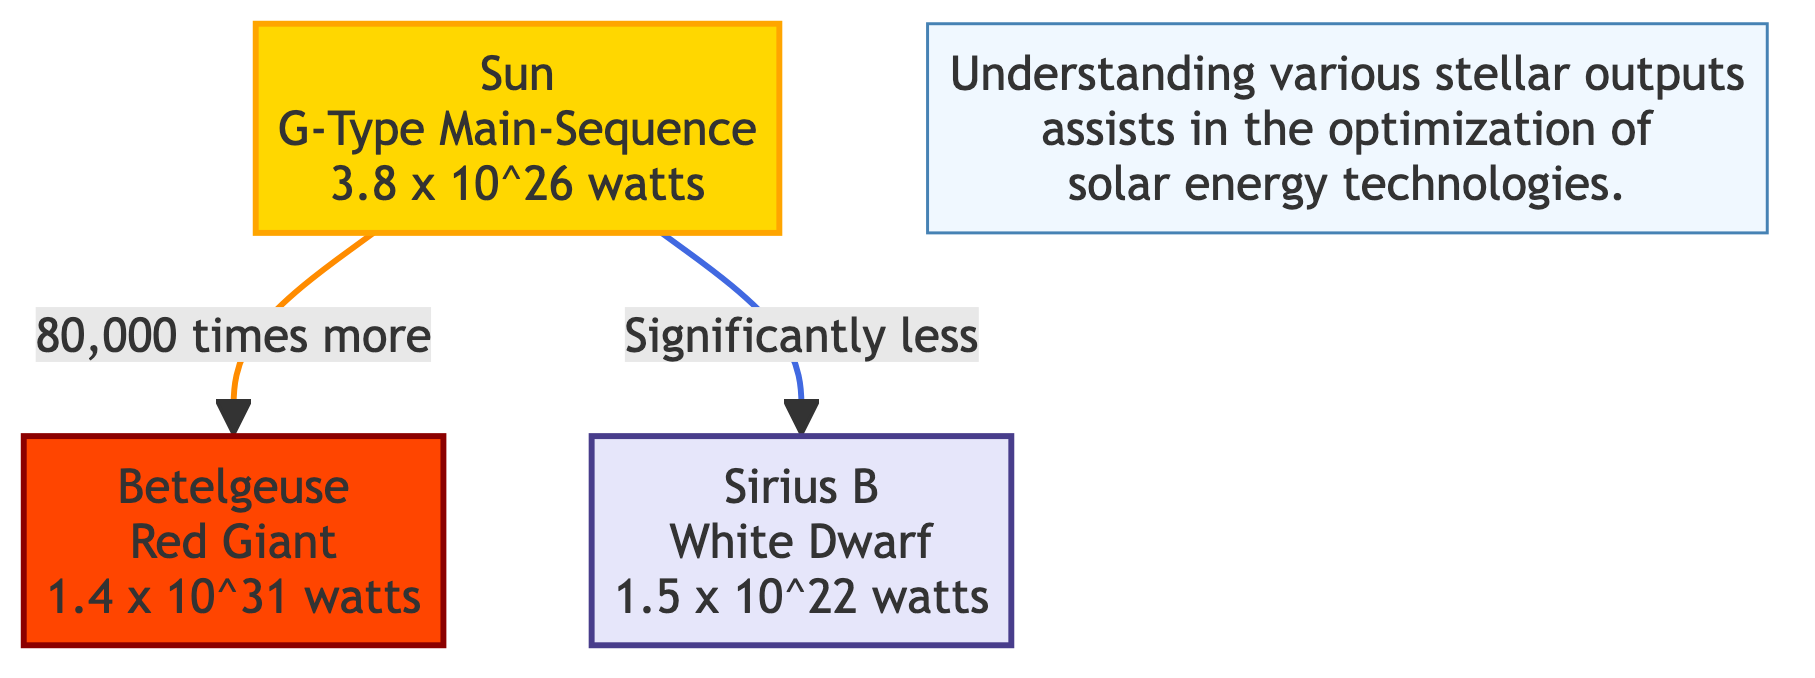What type of star is the Sun? The label next to the Sun in the diagram indicates that it is a G-Type Main-Sequence star.
Answer: G-Type Main-Sequence What is the energy output of Betelgeuse? The diagram specifies that Betelgeuse has an energy output of 1.4 x 10^31 watts.
Answer: 1.4 x 10^31 watts How does the energy output of the Sun compare to that of Sirius B? The diagram shows a directional relationship indicating that the Sun has significantly less energy output than Sirius B.
Answer: Significantly less How many types of stars are represented in the diagram? By counting the nodes, there are three types of stars represented: the Sun, Betelgeuse, and Sirius B.
Answer: Three What is the energy output of the Sun in watts? The diagram clearly states that the energy output of the Sun is 3.8 x 10^26 watts.
Answer: 3.8 x 10^26 watts What color represents white dwarfs in the diagram? The class definition in the diagram indicates that white dwarfs are represented in the color associated with the note, which is a light lavender shade.
Answer: Light lavender Why is it important to understand various stellar outputs according to the diagram? The note at the bottom of the diagram explains that understanding various stellar outputs assists in the optimization of solar energy technologies.
Answer: Optimization of solar energy technologies What is the energy output of Sirius B? The diagram states that the energy output of Sirius B is 1.5 x 10^22 watts.
Answer: 1.5 x 10^22 watts How much more energy does Betelgeuse output compared to the Sun? The diagram indicates that Betelgeuse outputs 80,000 times more energy than the Sun.
Answer: 80,000 times more 